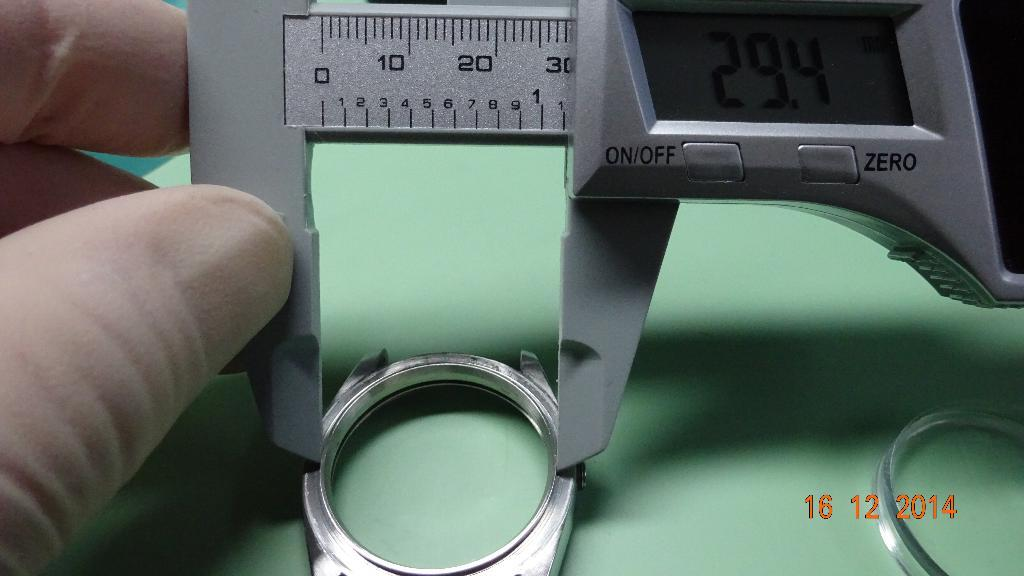<image>
Describe the image concisely. a silver measure with a reading of 29.4 